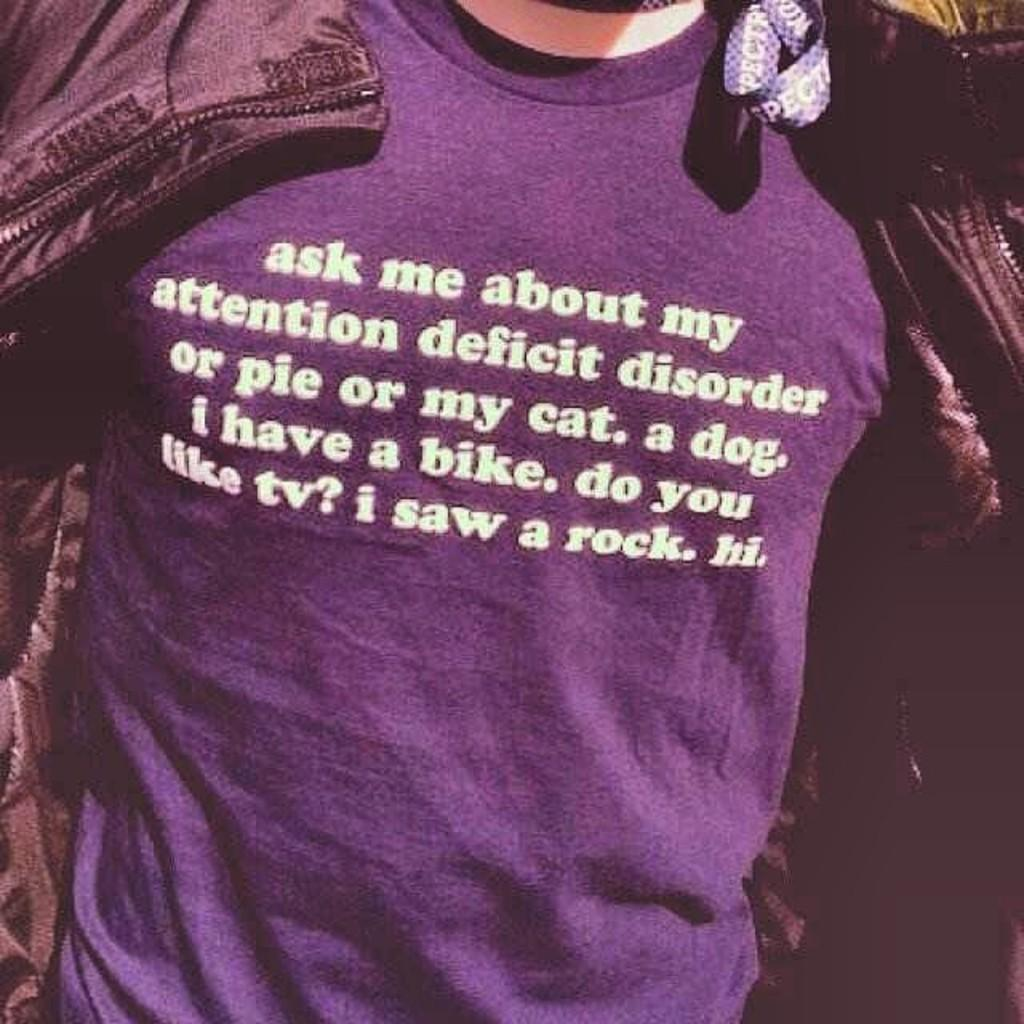What is the main subject of the picture? There is a person in the picture. What color is the shirt the person is wearing? The person is wearing a purple shirt. Is the person wearing any additional clothing over the shirt? Yes, the person is wearing a coat over the shirt. Is there any text or design on the coat or shirt? There is something written on the coat or shirt. What type of card can be seen floating in the air in the image? There is no card or any object floating in the air in the image. What fact about the air can be observed in the image? There is no specific fact about the air that can be observed in the image. 